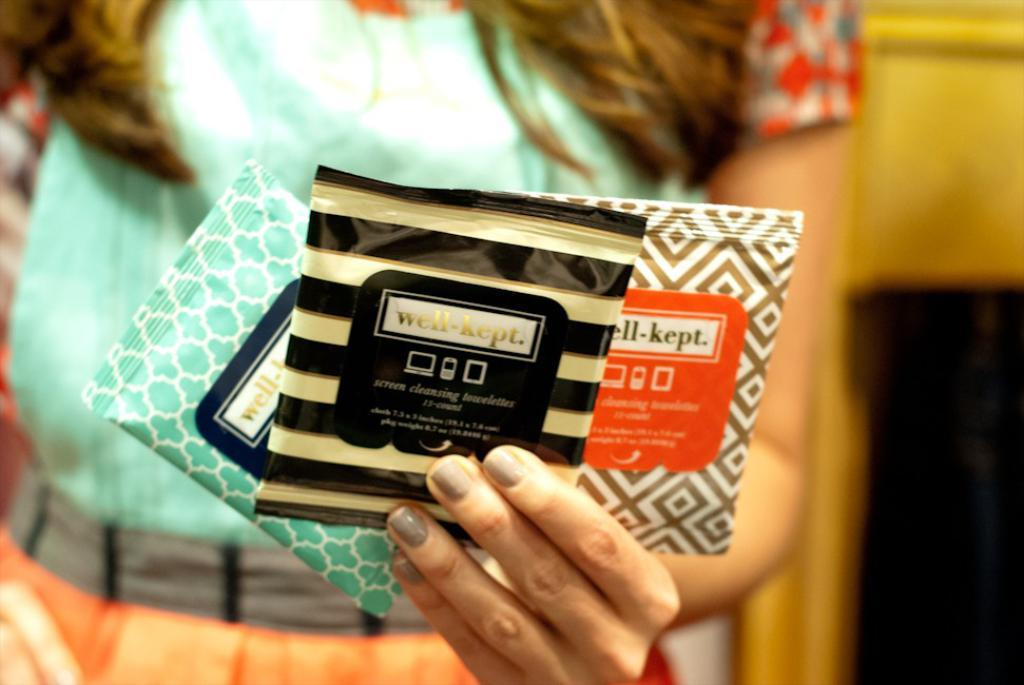Who is the main subject in the image? There is a woman in the image. What is the woman doing in the image? The woman is standing. What is the woman holding in the image? The woman is holding three different sachets. Can you describe the background of the image? The background of the image is blurry. What type of apple is growing on the linen in the image? There is no apple or linen present in the image. How many mines can be seen in the background of the image? There are no mines present in the image; the background is blurry. 